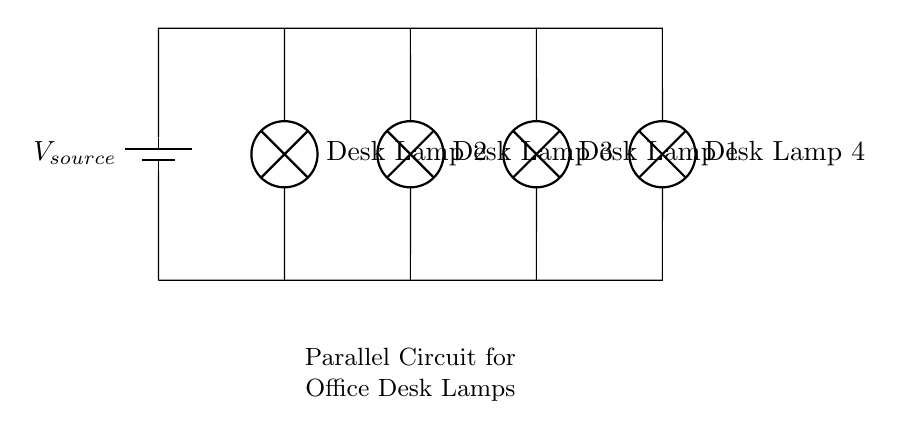What is the type of circuit shown? The circuit is a parallel circuit because multiple components (the desk lamps) are connected across the same voltage source, allowing each lamp to operate independently.
Answer: Parallel circuit How many desk lamps are connected in the circuit? There are four desk lamps connected in the circuit, as indicated by the labels on the diagram.
Answer: Four What is the relationship of the voltage across each desk lamp? In a parallel circuit, the voltage across each component is the same. Thus, the voltage across each desk lamp is equal to the voltage of the source.
Answer: Equal to the source voltage If one desk lamp fails, how does it affect the other lamps? Because the lamps are connected in parallel, if one lamp fails, the others will continue to operate normally, as they are all connected to the same source independently.
Answer: The others remain unaffected What happens to the total current when more lamps are added? In a parallel circuit, adding more lamps increases the total current in the circuit because each additional lamp provides another path for current flow, thereby increasing the total current drawn from the source.
Answer: Total current increases 